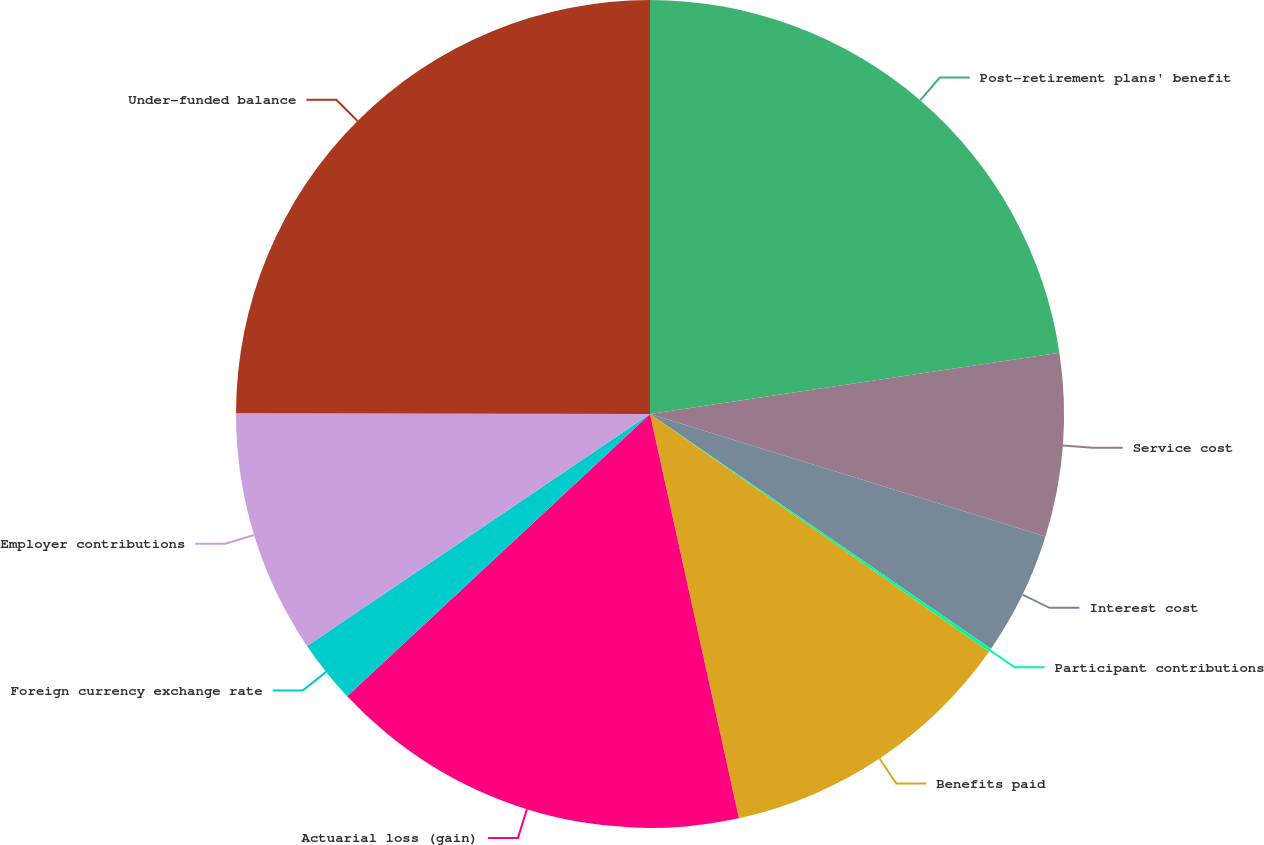Convert chart to OTSL. <chart><loc_0><loc_0><loc_500><loc_500><pie_chart><fcel>Post-retirement plans' benefit<fcel>Service cost<fcel>Interest cost<fcel>Participant contributions<fcel>Benefits paid<fcel>Actuarial loss (gain)<fcel>Foreign currency exchange rate<fcel>Employer contributions<fcel>Under-funded balance<nl><fcel>22.63%<fcel>7.15%<fcel>4.81%<fcel>0.14%<fcel>11.82%<fcel>16.5%<fcel>2.48%<fcel>9.49%<fcel>24.97%<nl></chart> 